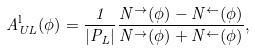Convert formula to latex. <formula><loc_0><loc_0><loc_500><loc_500>A _ { U L } ^ { \text {l} } ( \phi ) = \frac { 1 } { | P _ { L } | } \frac { N ^ { \rightarrow } ( \phi ) - N ^ { \leftarrow } ( \phi ) } { N ^ { \rightarrow } ( \phi ) + N ^ { \leftarrow } ( \phi ) } ,</formula> 